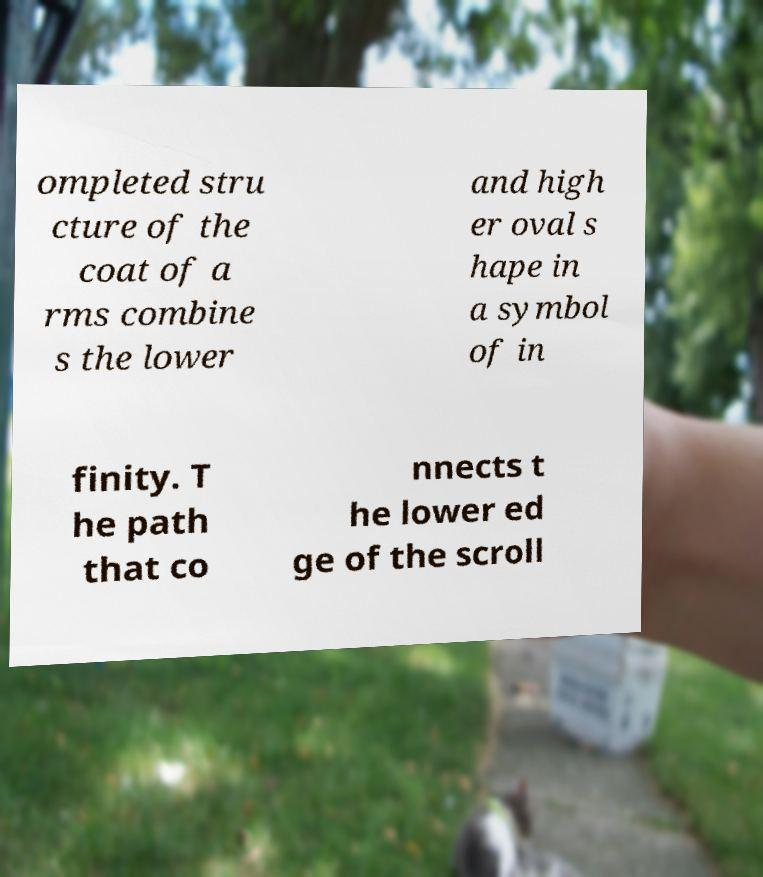Can you read and provide the text displayed in the image?This photo seems to have some interesting text. Can you extract and type it out for me? ompleted stru cture of the coat of a rms combine s the lower and high er oval s hape in a symbol of in finity. T he path that co nnects t he lower ed ge of the scroll 